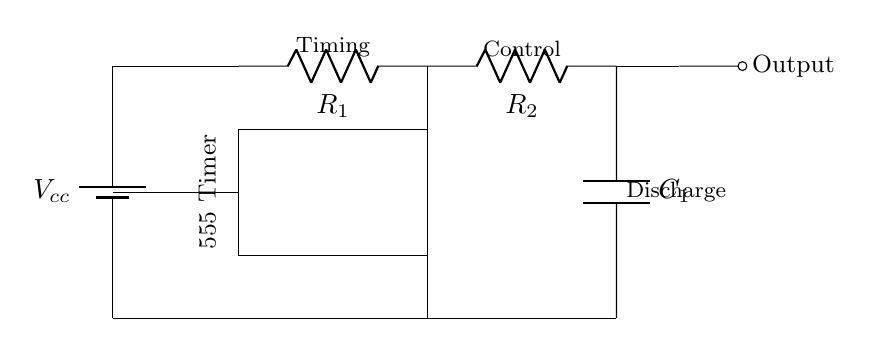What type of timer is used in this circuit? The circuit utilizes a 555 Timer IC, which is commonly used for timing applications. This can be identified from the rectangular component labeled "555 Timer" in the diagram.
Answer: 555 Timer What is the purpose of the capacitor in this circuit? The capacitor, labeled as C1 in the diagram, is used to store and release energy, which influences the timing interval for the timer. This can be deduced from the common function of capacitors in timer circuits.
Answer: Timing What are the resistor values connected to the timer? The diagram shows two resistors labeled R1 and R2, but their specific values are not indicated. However, they are part of the timing control mechanism of the circuit. Their actual resistance would be determined by the designer's requirements.
Answer: Not specified What connects the output of the 555 Timer to the rest of the circuit? The output is indicated by the short line labeled "Output," which connects directly to the corresponding output terminal of the 555 Timer. This connection is crucial as it indicates where the timing signal is produced.
Answer: Output terminal How does the capacitor influence the timing interval? The capacitor charges and discharges through the resistors R1 and R2, creating an exponential charge and discharge curve that determines the duration of the timer's output state. This fact is based on the time constant formula, which involves the resistance and capacitance values.
Answer: Duration What type of circuit is this? This circuit is a timer circuit, specifically designed for tracking durations, making it a timing circuit commonly used in presentation settings or media events. The components and their arrangement support this function.
Answer: Timer circuit 